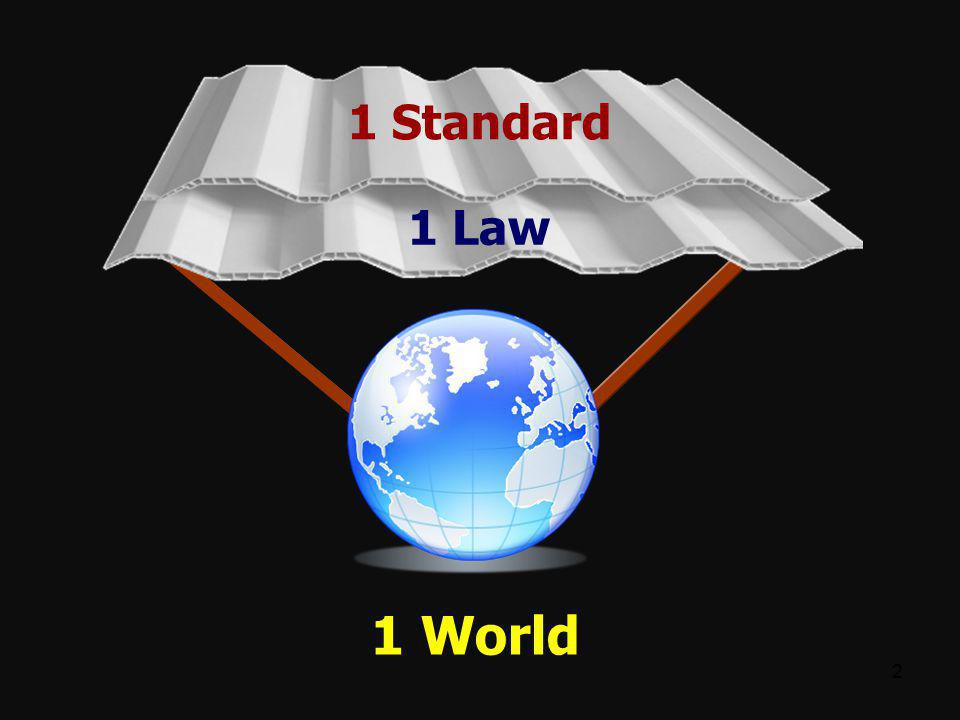What metaphorical significance can we derive from the image's design elements, such as the globe and the structure above it? The globe represents the Earth and signifies a collective human society. The structure above it, with its labels '1 Standard' and '1 Law', symbolizes a protective canopy. This metaphor suggests that unified standards and laws act as protective measures, ensuring a stable and secure world. The supporting beams connecting the globe and the structure emphasize the foundational role these concepts play in maintaining global order. 